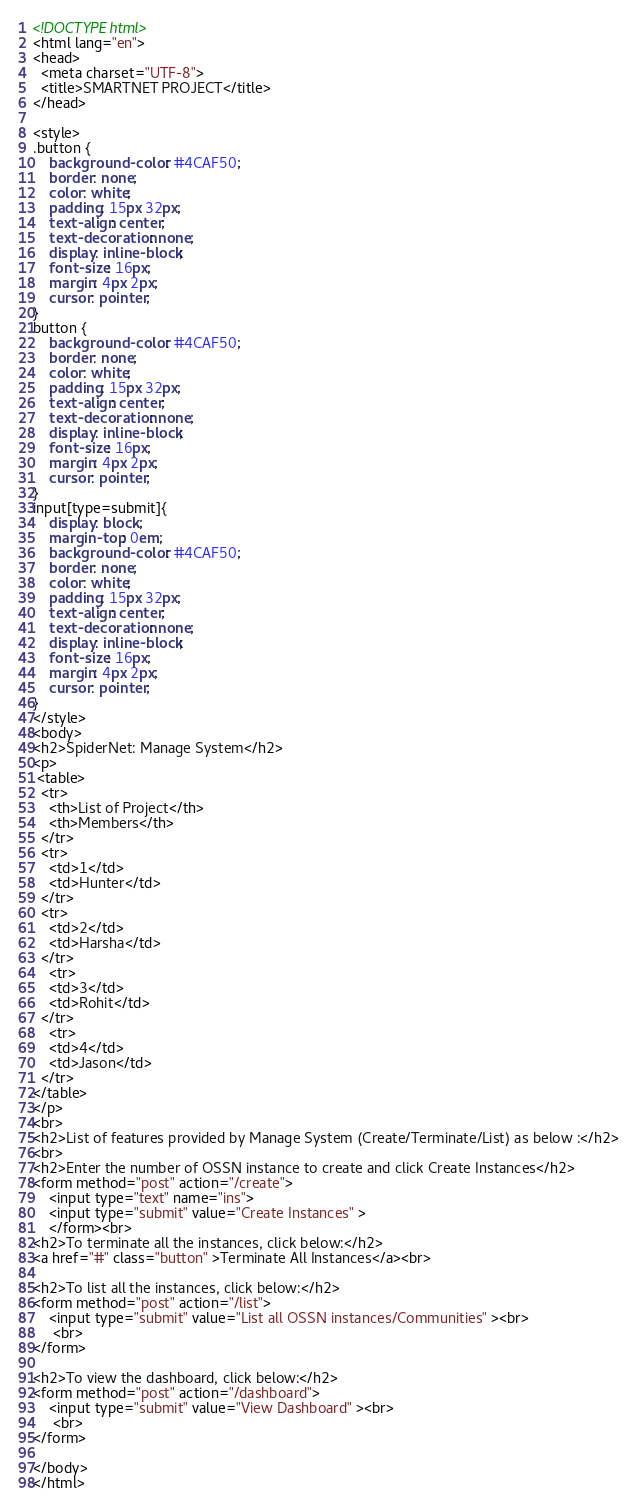<code> <loc_0><loc_0><loc_500><loc_500><_HTML_><!DOCTYPE html>
<html lang="en">
<head>
  <meta charset="UTF-8">
  <title>SMARTNET PROJECT</title>
</head>

<style>
.button {
    background-color: #4CAF50;
    border: none;
    color: white;
    padding: 15px 32px;
    text-align: center;
    text-decoration: none;
    display: inline-block;
    font-size: 16px;
    margin: 4px 2px;
    cursor: pointer;
}
button {
    background-color: #4CAF50;
    border: none;
    color: white;
    padding: 15px 32px;
    text-align: center;
    text-decoration: none;
    display: inline-block;
    font-size: 16px;
    margin: 4px 2px;
    cursor: pointer;
}
input[type=submit]{
    display: block;
    margin-top: 0em;
    background-color: #4CAF50;
    border: none;
    color: white;
    padding: 15px 32px;
    text-align: center;
    text-decoration: none;
    display: inline-block;
    font-size: 16px;
    margin: 4px 2px;
    cursor: pointer;
}
</style>
<body>
<h2>SpiderNet: Manage System</h2>
<p>
 <table>
  <tr>
    <th>List of Project</th>
    <th>Members</th>
  </tr>
  <tr>
    <td>1</td>
    <td>Hunter</td>
  </tr>
  <tr>
    <td>2</td>
    <td>Harsha</td>
  </tr>
    <tr>
    <td>3</td>
    <td>Rohit</td>
  </tr>
    <tr>
    <td>4</td>
    <td>Jason</td>
  </tr>
</table>
</p>
<br>
<h2>List of features provided by Manage System (Create/Terminate/List) as below :</h2>
<br>
<h2>Enter the number of OSSN instance to create and click Create Instances</h2>
<form method="post" action="/create">
    <input type="text" name="ins">
    <input type="submit" value="Create Instances" >
    </form><br>
<h2>To terminate all the instances, click below:</h2>
<a href="#" class="button" >Terminate All Instances</a><br>

<h2>To list all the instances, click below:</h2>
<form method="post" action="/list">
    <input type="submit" value="List all OSSN instances/Communities" ><br>
     <br>
</form>

<h2>To view the dashboard, click below:</h2>
<form method="post" action="/dashboard">
    <input type="submit" value="View Dashboard" ><br>
     <br>
</form>

</body>
</html>
</code> 